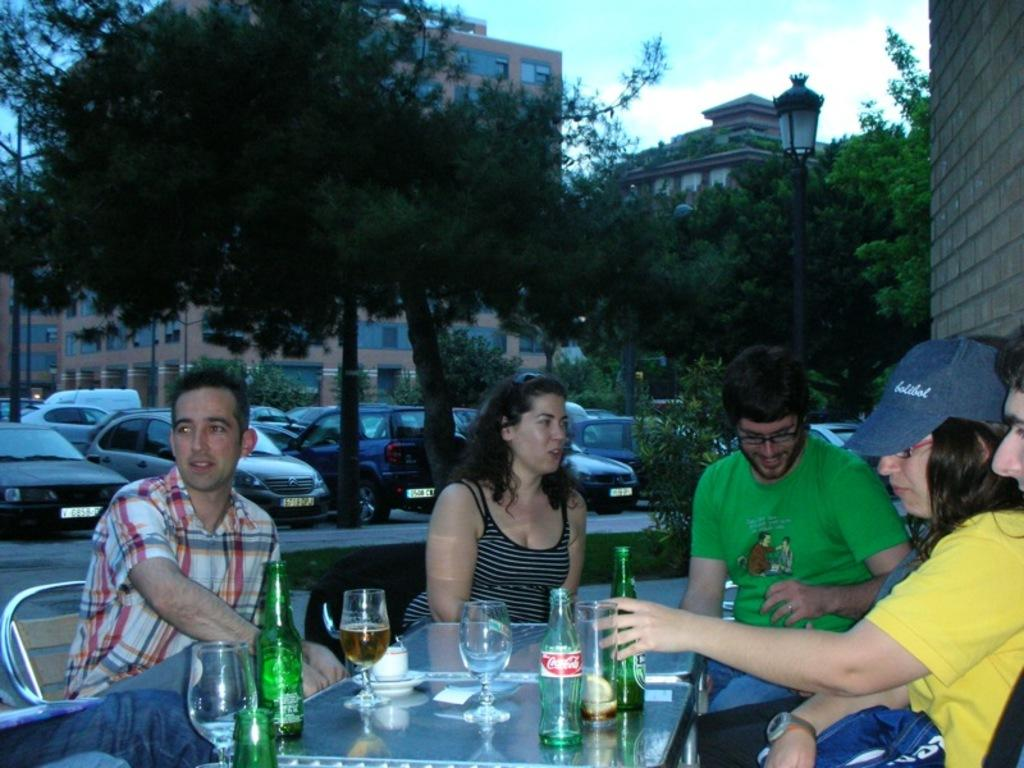What are the people in the image doing? People are sitting on chairs around a table in the image. What objects can be seen on the table? There are glass bottles and glasses on the table. What can be seen in the background of the image? Cars, trees, and buildings are visible in the background. How many fangs can be seen on the deer in the image? There is no deer present in the image, and therefore no fangs can be seen. What day of the week is depicted in the image? The image does not depict a specific day of the week. 